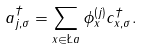Convert formula to latex. <formula><loc_0><loc_0><loc_500><loc_500>a ^ { \dagger } _ { j , \sigma } = \sum _ { x \in \L a } \phi ^ { ( j ) } _ { x } c ^ { \dagger } _ { x , \sigma } .</formula> 